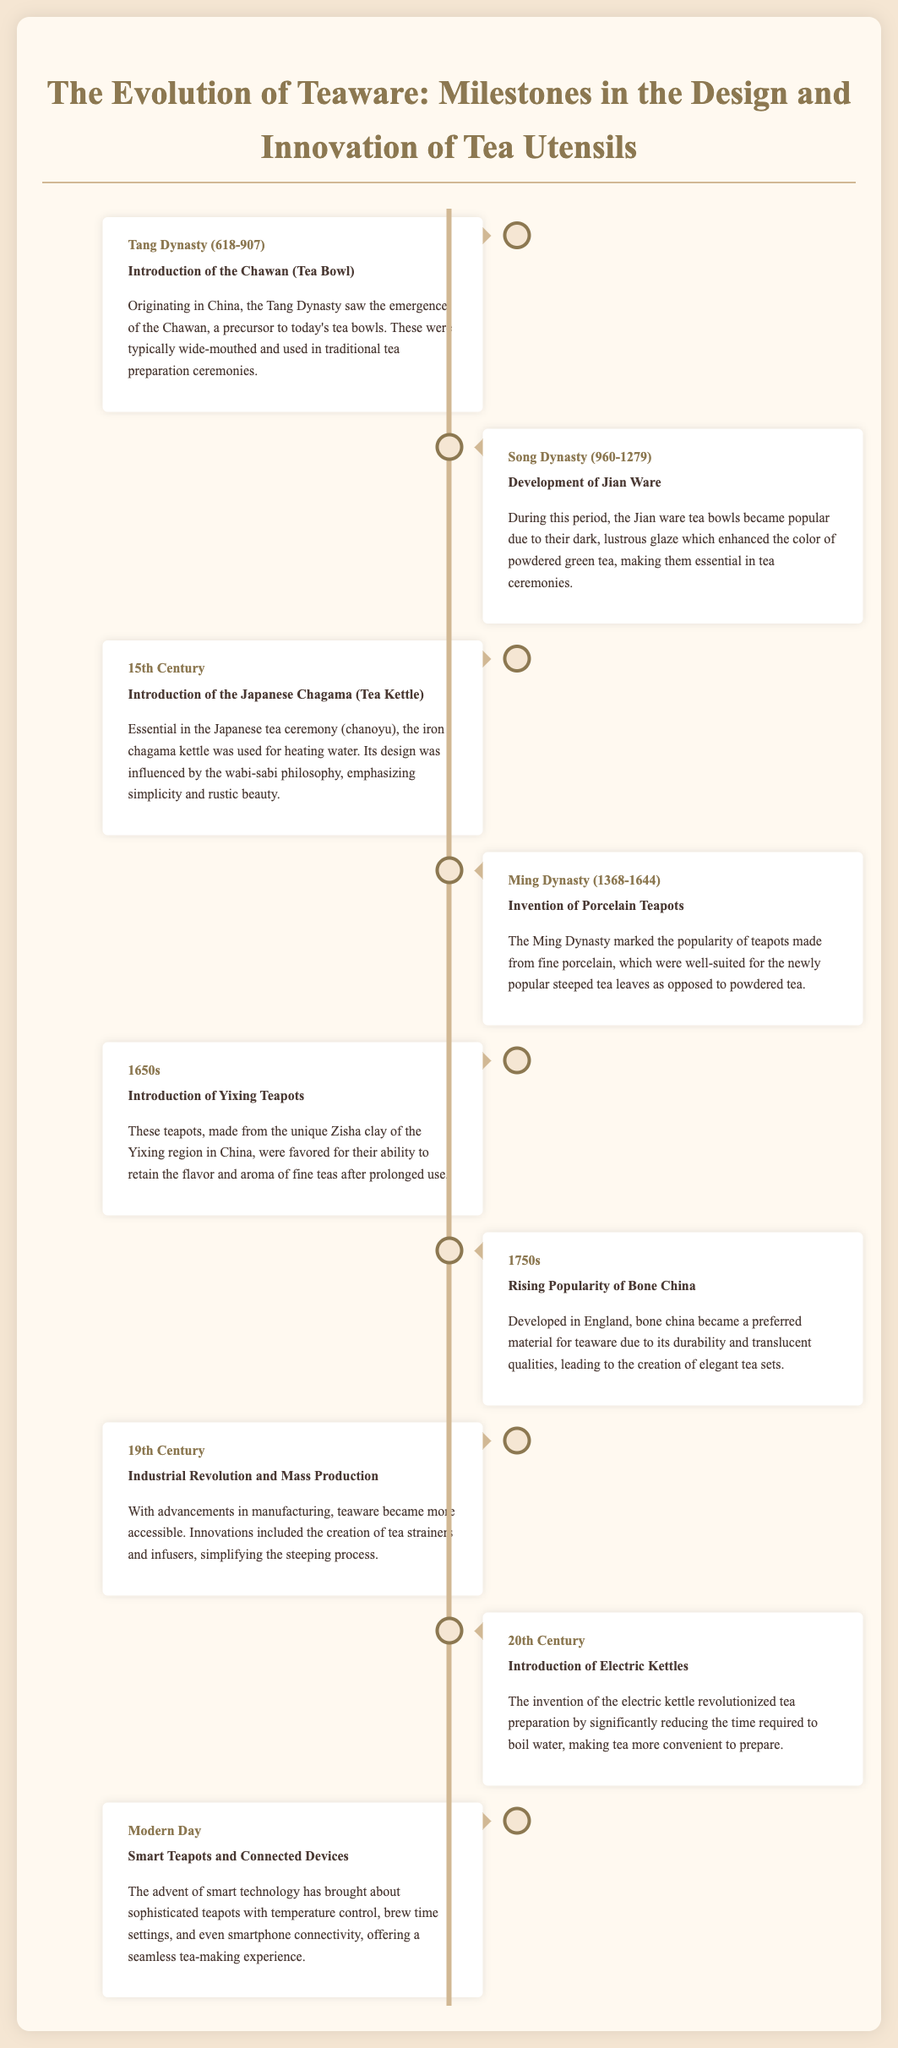What was introduced during the Tang Dynasty? The document states that the Chawan (Tea Bowl) was introduced during the Tang Dynasty.
Answer: Chawan (Tea Bowl) What type of teaware became popular during the Song Dynasty? The Jian ware tea bowls became popular during the Song Dynasty, according to the document.
Answer: Jian Ware When was the Japanese Chagama introduced? The document indicates that the Japanese Chagama (Tea Kettle) was introduced in the 15th Century.
Answer: 15th Century What innovation occurred in the Ming Dynasty related to teapots? The Ming Dynasty marked the invention of porcelain teapots, as stated in the document.
Answer: Porcelain Teapots What material became popular for teaware in the 1750s? The document notes that bone china rose in popularity for teaware during the 1750s.
Answer: Bone china How did the Industrial Revolution affect teaware? The document mentions that the Industrial Revolution led to mass production and made teaware more accessible.
Answer: Mass Production What significant invention was introduced in the 20th Century? According to the document, the introduction of electric kettles was a significant development in the 20th Century.
Answer: Electric kettles What is a modern advancement in teaware mentioned in the document? The document states that smart technology has led to the creation of smart teapots and connected devices.
Answer: Smart teapots In which dynasty did the introduction of Zisha clay occur? The introduction of Yixing Teapots made from Zisha clay occurred in the 1650s, as highlighted in the document.
Answer: 1650s 